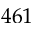<formula> <loc_0><loc_0><loc_500><loc_500>4 6 1</formula> 